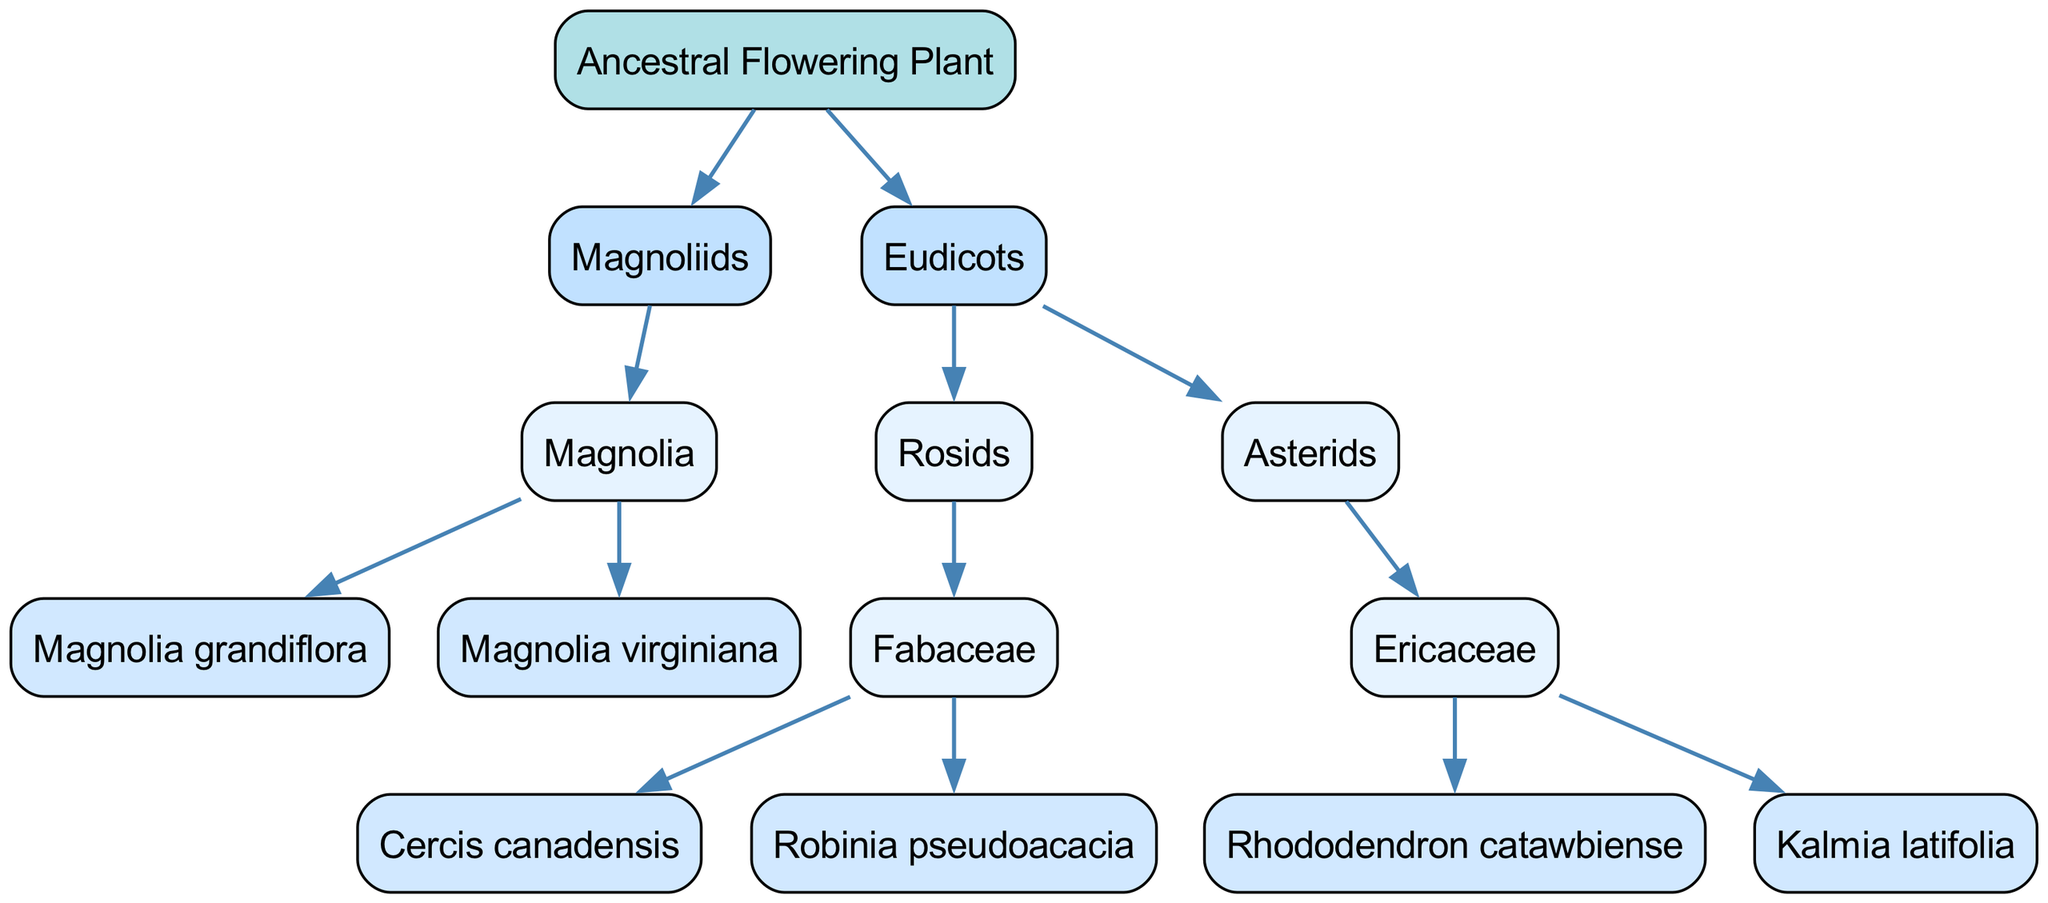What is the root of the evolutionary lineage? The diagram indicates that the root of the evolutionary lineage is labeled as "Ancestral Flowering Plant." This is the starting point from which all other branches and descendants flow.
Answer: Ancestral Flowering Plant How many primary branches are represented in the diagram? The diagram shows two primary branches: "Magnoliids" and "Eudicots." These branches emerge directly from the root node, indicating the major lineages of flowering plants.
Answer: 2 Which descendant is under the "Magnolia" genus? The diagram shows that "Magnolia grandiflora" and "Magnolia virginiana" are the descendants listed under the "Magnolia" genus. This indicates that these two species fall under the lineage of that particular genus.
Answer: Magnolia grandiflora, Magnolia virginiana What taxa does the "Eudicots" branch include? The "Eudicots" branch further divides into two smaller branches, "Rosids" and "Asterids." This division signals that "Eudicots" encompasses multiple lineages, suggesting a more complex evolutionary path.
Answer: Rosids, Asterids Which family is included under the "Rosids" branch? "Fabaceae" is the family included under the "Rosids" branch according to the diagram. This family is an example of the various groups that fall under the "Eudicots" classification.
Answer: Fabaceae Which two species are part of the "Ericaceae" family? The species "Rhododendron catawbiense" and "Kalmia latifolia" are both listed under the "Ericaceae" family in the diagram. This shows the specific connection between these taxa and their family within the broader lineage.
Answer: Rhododendron catawbiense, Kalmia latifolia How many species are found in the "Fabaceae" family on the diagram? The diagram displays two species under the "Fabaceae" family: "Cercis canadensis" and "Robinia pseudoacacia." This indicates the specific members of this plant family within the ecological lineage represented.
Answer: 2 Which genus includes "Rhododendron catawbiense"? The "Rhododendron catawbiense" species belongs to the "Ericaceae" genus as illustrated in the diagram. This shows the classification hierarchy leading from genus to species.
Answer: Ericaceae Which group is a descendant of "Eudicots"? The diagram illustrates that both "Rosids" and "Asterids" are descendants of the "Eudicots" branch. This indicates that the "Eudicots" encompasses a variety of plant lineages within its classification.
Answer: Rosids, Asterids 